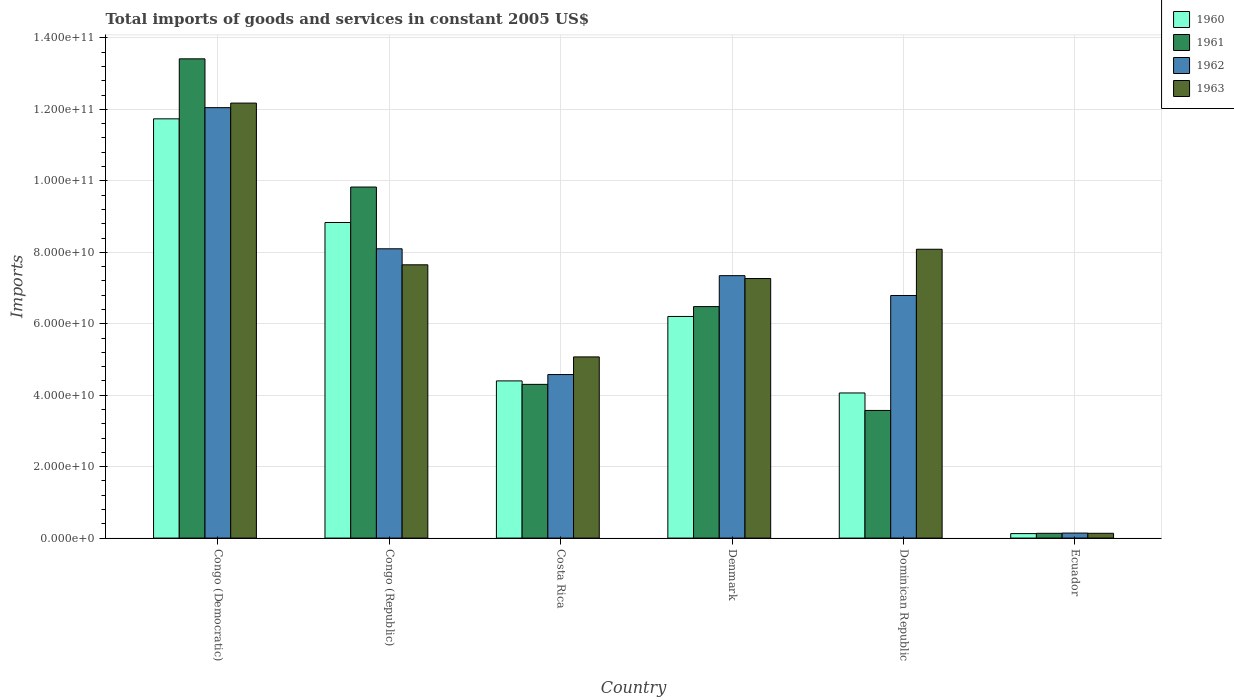How many groups of bars are there?
Offer a very short reply. 6. Are the number of bars on each tick of the X-axis equal?
Your response must be concise. Yes. How many bars are there on the 4th tick from the left?
Provide a short and direct response. 4. In how many cases, is the number of bars for a given country not equal to the number of legend labels?
Make the answer very short. 0. What is the total imports of goods and services in 1962 in Costa Rica?
Your answer should be compact. 4.58e+1. Across all countries, what is the maximum total imports of goods and services in 1961?
Provide a succinct answer. 1.34e+11. Across all countries, what is the minimum total imports of goods and services in 1963?
Offer a terse response. 1.34e+09. In which country was the total imports of goods and services in 1960 maximum?
Your answer should be compact. Congo (Democratic). In which country was the total imports of goods and services in 1961 minimum?
Your answer should be compact. Ecuador. What is the total total imports of goods and services in 1960 in the graph?
Offer a terse response. 3.54e+11. What is the difference between the total imports of goods and services in 1963 in Denmark and that in Ecuador?
Offer a very short reply. 7.13e+1. What is the difference between the total imports of goods and services in 1962 in Denmark and the total imports of goods and services in 1960 in Costa Rica?
Your answer should be very brief. 2.95e+1. What is the average total imports of goods and services in 1961 per country?
Your answer should be compact. 6.29e+1. What is the difference between the total imports of goods and services of/in 1962 and total imports of goods and services of/in 1960 in Ecuador?
Ensure brevity in your answer.  1.45e+08. In how many countries, is the total imports of goods and services in 1960 greater than 44000000000 US$?
Give a very brief answer. 4. What is the ratio of the total imports of goods and services in 1963 in Costa Rica to that in Denmark?
Your answer should be compact. 0.7. Is the difference between the total imports of goods and services in 1962 in Congo (Democratic) and Denmark greater than the difference between the total imports of goods and services in 1960 in Congo (Democratic) and Denmark?
Make the answer very short. No. What is the difference between the highest and the second highest total imports of goods and services in 1960?
Your response must be concise. -5.53e+1. What is the difference between the highest and the lowest total imports of goods and services in 1960?
Provide a short and direct response. 1.16e+11. In how many countries, is the total imports of goods and services in 1962 greater than the average total imports of goods and services in 1962 taken over all countries?
Offer a very short reply. 4. Is the sum of the total imports of goods and services in 1962 in Costa Rica and Denmark greater than the maximum total imports of goods and services in 1960 across all countries?
Give a very brief answer. Yes. Is it the case that in every country, the sum of the total imports of goods and services in 1962 and total imports of goods and services in 1961 is greater than the total imports of goods and services in 1960?
Your answer should be compact. Yes. How many countries are there in the graph?
Provide a short and direct response. 6. What is the difference between two consecutive major ticks on the Y-axis?
Provide a succinct answer. 2.00e+1. Are the values on the major ticks of Y-axis written in scientific E-notation?
Keep it short and to the point. Yes. Does the graph contain grids?
Offer a terse response. Yes. Where does the legend appear in the graph?
Your answer should be compact. Top right. How many legend labels are there?
Provide a short and direct response. 4. What is the title of the graph?
Offer a terse response. Total imports of goods and services in constant 2005 US$. What is the label or title of the Y-axis?
Your answer should be compact. Imports. What is the Imports in 1960 in Congo (Democratic)?
Provide a succinct answer. 1.17e+11. What is the Imports of 1961 in Congo (Democratic)?
Give a very brief answer. 1.34e+11. What is the Imports of 1962 in Congo (Democratic)?
Give a very brief answer. 1.20e+11. What is the Imports in 1963 in Congo (Democratic)?
Offer a very short reply. 1.22e+11. What is the Imports of 1960 in Congo (Republic)?
Provide a short and direct response. 8.83e+1. What is the Imports of 1961 in Congo (Republic)?
Your response must be concise. 9.83e+1. What is the Imports of 1962 in Congo (Republic)?
Offer a terse response. 8.10e+1. What is the Imports in 1963 in Congo (Republic)?
Your answer should be compact. 7.65e+1. What is the Imports in 1960 in Costa Rica?
Make the answer very short. 4.40e+1. What is the Imports in 1961 in Costa Rica?
Your answer should be compact. 4.30e+1. What is the Imports in 1962 in Costa Rica?
Ensure brevity in your answer.  4.58e+1. What is the Imports of 1963 in Costa Rica?
Provide a short and direct response. 5.07e+1. What is the Imports of 1960 in Denmark?
Keep it short and to the point. 6.20e+1. What is the Imports of 1961 in Denmark?
Offer a very short reply. 6.48e+1. What is the Imports of 1962 in Denmark?
Provide a succinct answer. 7.35e+1. What is the Imports of 1963 in Denmark?
Your answer should be compact. 7.27e+1. What is the Imports of 1960 in Dominican Republic?
Ensure brevity in your answer.  4.06e+1. What is the Imports of 1961 in Dominican Republic?
Offer a very short reply. 3.57e+1. What is the Imports in 1962 in Dominican Republic?
Your answer should be compact. 6.79e+1. What is the Imports in 1963 in Dominican Republic?
Make the answer very short. 8.09e+1. What is the Imports in 1960 in Ecuador?
Give a very brief answer. 1.26e+09. What is the Imports in 1961 in Ecuador?
Provide a succinct answer. 1.34e+09. What is the Imports in 1962 in Ecuador?
Your answer should be compact. 1.40e+09. What is the Imports of 1963 in Ecuador?
Your response must be concise. 1.34e+09. Across all countries, what is the maximum Imports in 1960?
Offer a terse response. 1.17e+11. Across all countries, what is the maximum Imports in 1961?
Give a very brief answer. 1.34e+11. Across all countries, what is the maximum Imports of 1962?
Provide a short and direct response. 1.20e+11. Across all countries, what is the maximum Imports in 1963?
Your response must be concise. 1.22e+11. Across all countries, what is the minimum Imports of 1960?
Your response must be concise. 1.26e+09. Across all countries, what is the minimum Imports in 1961?
Provide a succinct answer. 1.34e+09. Across all countries, what is the minimum Imports in 1962?
Provide a succinct answer. 1.40e+09. Across all countries, what is the minimum Imports in 1963?
Make the answer very short. 1.34e+09. What is the total Imports in 1960 in the graph?
Give a very brief answer. 3.54e+11. What is the total Imports of 1961 in the graph?
Keep it short and to the point. 3.77e+11. What is the total Imports in 1962 in the graph?
Make the answer very short. 3.90e+11. What is the total Imports in 1963 in the graph?
Give a very brief answer. 4.04e+11. What is the difference between the Imports in 1960 in Congo (Democratic) and that in Congo (Republic)?
Give a very brief answer. 2.90e+1. What is the difference between the Imports in 1961 in Congo (Democratic) and that in Congo (Republic)?
Your answer should be compact. 3.59e+1. What is the difference between the Imports of 1962 in Congo (Democratic) and that in Congo (Republic)?
Offer a terse response. 3.95e+1. What is the difference between the Imports of 1963 in Congo (Democratic) and that in Congo (Republic)?
Your answer should be very brief. 4.53e+1. What is the difference between the Imports in 1960 in Congo (Democratic) and that in Costa Rica?
Offer a very short reply. 7.34e+1. What is the difference between the Imports in 1961 in Congo (Democratic) and that in Costa Rica?
Keep it short and to the point. 9.11e+1. What is the difference between the Imports in 1962 in Congo (Democratic) and that in Costa Rica?
Provide a succinct answer. 7.47e+1. What is the difference between the Imports of 1963 in Congo (Democratic) and that in Costa Rica?
Your answer should be compact. 7.11e+1. What is the difference between the Imports in 1960 in Congo (Democratic) and that in Denmark?
Your response must be concise. 5.53e+1. What is the difference between the Imports in 1961 in Congo (Democratic) and that in Denmark?
Offer a terse response. 6.94e+1. What is the difference between the Imports of 1962 in Congo (Democratic) and that in Denmark?
Keep it short and to the point. 4.70e+1. What is the difference between the Imports of 1963 in Congo (Democratic) and that in Denmark?
Your response must be concise. 4.91e+1. What is the difference between the Imports of 1960 in Congo (Democratic) and that in Dominican Republic?
Provide a succinct answer. 7.67e+1. What is the difference between the Imports of 1961 in Congo (Democratic) and that in Dominican Republic?
Your answer should be compact. 9.84e+1. What is the difference between the Imports in 1962 in Congo (Democratic) and that in Dominican Republic?
Provide a succinct answer. 5.26e+1. What is the difference between the Imports in 1963 in Congo (Democratic) and that in Dominican Republic?
Your answer should be compact. 4.09e+1. What is the difference between the Imports in 1960 in Congo (Democratic) and that in Ecuador?
Your answer should be compact. 1.16e+11. What is the difference between the Imports of 1961 in Congo (Democratic) and that in Ecuador?
Your answer should be compact. 1.33e+11. What is the difference between the Imports of 1962 in Congo (Democratic) and that in Ecuador?
Offer a terse response. 1.19e+11. What is the difference between the Imports in 1963 in Congo (Democratic) and that in Ecuador?
Offer a very short reply. 1.20e+11. What is the difference between the Imports in 1960 in Congo (Republic) and that in Costa Rica?
Provide a short and direct response. 4.43e+1. What is the difference between the Imports of 1961 in Congo (Republic) and that in Costa Rica?
Offer a very short reply. 5.52e+1. What is the difference between the Imports in 1962 in Congo (Republic) and that in Costa Rica?
Your answer should be compact. 3.52e+1. What is the difference between the Imports in 1963 in Congo (Republic) and that in Costa Rica?
Offer a terse response. 2.58e+1. What is the difference between the Imports of 1960 in Congo (Republic) and that in Denmark?
Your response must be concise. 2.63e+1. What is the difference between the Imports in 1961 in Congo (Republic) and that in Denmark?
Your answer should be compact. 3.35e+1. What is the difference between the Imports of 1962 in Congo (Republic) and that in Denmark?
Your response must be concise. 7.52e+09. What is the difference between the Imports of 1963 in Congo (Republic) and that in Denmark?
Ensure brevity in your answer.  3.84e+09. What is the difference between the Imports of 1960 in Congo (Republic) and that in Dominican Republic?
Keep it short and to the point. 4.77e+1. What is the difference between the Imports of 1961 in Congo (Republic) and that in Dominican Republic?
Keep it short and to the point. 6.25e+1. What is the difference between the Imports of 1962 in Congo (Republic) and that in Dominican Republic?
Ensure brevity in your answer.  1.31e+1. What is the difference between the Imports in 1963 in Congo (Republic) and that in Dominican Republic?
Keep it short and to the point. -4.35e+09. What is the difference between the Imports of 1960 in Congo (Republic) and that in Ecuador?
Ensure brevity in your answer.  8.71e+1. What is the difference between the Imports in 1961 in Congo (Republic) and that in Ecuador?
Provide a succinct answer. 9.69e+1. What is the difference between the Imports of 1962 in Congo (Republic) and that in Ecuador?
Make the answer very short. 7.96e+1. What is the difference between the Imports in 1963 in Congo (Republic) and that in Ecuador?
Your response must be concise. 7.52e+1. What is the difference between the Imports in 1960 in Costa Rica and that in Denmark?
Your answer should be compact. -1.80e+1. What is the difference between the Imports of 1961 in Costa Rica and that in Denmark?
Provide a short and direct response. -2.18e+1. What is the difference between the Imports of 1962 in Costa Rica and that in Denmark?
Provide a succinct answer. -2.77e+1. What is the difference between the Imports in 1963 in Costa Rica and that in Denmark?
Ensure brevity in your answer.  -2.19e+1. What is the difference between the Imports of 1960 in Costa Rica and that in Dominican Republic?
Provide a succinct answer. 3.38e+09. What is the difference between the Imports of 1961 in Costa Rica and that in Dominican Republic?
Offer a very short reply. 7.30e+09. What is the difference between the Imports in 1962 in Costa Rica and that in Dominican Republic?
Offer a terse response. -2.21e+1. What is the difference between the Imports in 1963 in Costa Rica and that in Dominican Republic?
Keep it short and to the point. -3.01e+1. What is the difference between the Imports in 1960 in Costa Rica and that in Ecuador?
Offer a terse response. 4.27e+1. What is the difference between the Imports of 1961 in Costa Rica and that in Ecuador?
Ensure brevity in your answer.  4.17e+1. What is the difference between the Imports of 1962 in Costa Rica and that in Ecuador?
Your response must be concise. 4.44e+1. What is the difference between the Imports of 1963 in Costa Rica and that in Ecuador?
Your answer should be compact. 4.94e+1. What is the difference between the Imports in 1960 in Denmark and that in Dominican Republic?
Make the answer very short. 2.14e+1. What is the difference between the Imports in 1961 in Denmark and that in Dominican Republic?
Provide a short and direct response. 2.91e+1. What is the difference between the Imports in 1962 in Denmark and that in Dominican Republic?
Provide a short and direct response. 5.55e+09. What is the difference between the Imports of 1963 in Denmark and that in Dominican Republic?
Offer a very short reply. -8.19e+09. What is the difference between the Imports in 1960 in Denmark and that in Ecuador?
Ensure brevity in your answer.  6.08e+1. What is the difference between the Imports in 1961 in Denmark and that in Ecuador?
Offer a terse response. 6.35e+1. What is the difference between the Imports of 1962 in Denmark and that in Ecuador?
Keep it short and to the point. 7.21e+1. What is the difference between the Imports of 1963 in Denmark and that in Ecuador?
Give a very brief answer. 7.13e+1. What is the difference between the Imports in 1960 in Dominican Republic and that in Ecuador?
Offer a terse response. 3.94e+1. What is the difference between the Imports of 1961 in Dominican Republic and that in Ecuador?
Make the answer very short. 3.44e+1. What is the difference between the Imports of 1962 in Dominican Republic and that in Ecuador?
Offer a very short reply. 6.65e+1. What is the difference between the Imports of 1963 in Dominican Republic and that in Ecuador?
Provide a succinct answer. 7.95e+1. What is the difference between the Imports of 1960 in Congo (Democratic) and the Imports of 1961 in Congo (Republic)?
Provide a succinct answer. 1.91e+1. What is the difference between the Imports in 1960 in Congo (Democratic) and the Imports in 1962 in Congo (Republic)?
Provide a succinct answer. 3.64e+1. What is the difference between the Imports in 1960 in Congo (Democratic) and the Imports in 1963 in Congo (Republic)?
Your response must be concise. 4.09e+1. What is the difference between the Imports of 1961 in Congo (Democratic) and the Imports of 1962 in Congo (Republic)?
Your answer should be very brief. 5.32e+1. What is the difference between the Imports of 1961 in Congo (Democratic) and the Imports of 1963 in Congo (Republic)?
Make the answer very short. 5.77e+1. What is the difference between the Imports of 1962 in Congo (Democratic) and the Imports of 1963 in Congo (Republic)?
Offer a very short reply. 4.40e+1. What is the difference between the Imports of 1960 in Congo (Democratic) and the Imports of 1961 in Costa Rica?
Provide a succinct answer. 7.43e+1. What is the difference between the Imports in 1960 in Congo (Democratic) and the Imports in 1962 in Costa Rica?
Keep it short and to the point. 7.16e+1. What is the difference between the Imports in 1960 in Congo (Democratic) and the Imports in 1963 in Costa Rica?
Offer a very short reply. 6.66e+1. What is the difference between the Imports of 1961 in Congo (Democratic) and the Imports of 1962 in Costa Rica?
Give a very brief answer. 8.84e+1. What is the difference between the Imports in 1961 in Congo (Democratic) and the Imports in 1963 in Costa Rica?
Provide a succinct answer. 8.34e+1. What is the difference between the Imports in 1962 in Congo (Democratic) and the Imports in 1963 in Costa Rica?
Provide a short and direct response. 6.98e+1. What is the difference between the Imports of 1960 in Congo (Democratic) and the Imports of 1961 in Denmark?
Your answer should be compact. 5.26e+1. What is the difference between the Imports in 1960 in Congo (Democratic) and the Imports in 1962 in Denmark?
Keep it short and to the point. 4.39e+1. What is the difference between the Imports in 1960 in Congo (Democratic) and the Imports in 1963 in Denmark?
Your answer should be very brief. 4.47e+1. What is the difference between the Imports in 1961 in Congo (Democratic) and the Imports in 1962 in Denmark?
Keep it short and to the point. 6.07e+1. What is the difference between the Imports in 1961 in Congo (Democratic) and the Imports in 1963 in Denmark?
Provide a succinct answer. 6.15e+1. What is the difference between the Imports in 1962 in Congo (Democratic) and the Imports in 1963 in Denmark?
Provide a short and direct response. 4.78e+1. What is the difference between the Imports of 1960 in Congo (Democratic) and the Imports of 1961 in Dominican Republic?
Give a very brief answer. 8.16e+1. What is the difference between the Imports in 1960 in Congo (Democratic) and the Imports in 1962 in Dominican Republic?
Offer a terse response. 4.95e+1. What is the difference between the Imports of 1960 in Congo (Democratic) and the Imports of 1963 in Dominican Republic?
Your response must be concise. 3.65e+1. What is the difference between the Imports of 1961 in Congo (Democratic) and the Imports of 1962 in Dominican Republic?
Your answer should be compact. 6.62e+1. What is the difference between the Imports in 1961 in Congo (Democratic) and the Imports in 1963 in Dominican Republic?
Keep it short and to the point. 5.33e+1. What is the difference between the Imports of 1962 in Congo (Democratic) and the Imports of 1963 in Dominican Republic?
Your response must be concise. 3.96e+1. What is the difference between the Imports of 1960 in Congo (Democratic) and the Imports of 1961 in Ecuador?
Give a very brief answer. 1.16e+11. What is the difference between the Imports in 1960 in Congo (Democratic) and the Imports in 1962 in Ecuador?
Your answer should be very brief. 1.16e+11. What is the difference between the Imports in 1960 in Congo (Democratic) and the Imports in 1963 in Ecuador?
Make the answer very short. 1.16e+11. What is the difference between the Imports of 1961 in Congo (Democratic) and the Imports of 1962 in Ecuador?
Make the answer very short. 1.33e+11. What is the difference between the Imports of 1961 in Congo (Democratic) and the Imports of 1963 in Ecuador?
Provide a succinct answer. 1.33e+11. What is the difference between the Imports of 1962 in Congo (Democratic) and the Imports of 1963 in Ecuador?
Give a very brief answer. 1.19e+11. What is the difference between the Imports in 1960 in Congo (Republic) and the Imports in 1961 in Costa Rica?
Ensure brevity in your answer.  4.53e+1. What is the difference between the Imports of 1960 in Congo (Republic) and the Imports of 1962 in Costa Rica?
Provide a succinct answer. 4.26e+1. What is the difference between the Imports in 1960 in Congo (Republic) and the Imports in 1963 in Costa Rica?
Offer a very short reply. 3.76e+1. What is the difference between the Imports in 1961 in Congo (Republic) and the Imports in 1962 in Costa Rica?
Offer a terse response. 5.25e+1. What is the difference between the Imports of 1961 in Congo (Republic) and the Imports of 1963 in Costa Rica?
Your answer should be very brief. 4.76e+1. What is the difference between the Imports of 1962 in Congo (Republic) and the Imports of 1963 in Costa Rica?
Provide a short and direct response. 3.03e+1. What is the difference between the Imports in 1960 in Congo (Republic) and the Imports in 1961 in Denmark?
Provide a succinct answer. 2.35e+1. What is the difference between the Imports in 1960 in Congo (Republic) and the Imports in 1962 in Denmark?
Keep it short and to the point. 1.49e+1. What is the difference between the Imports of 1960 in Congo (Republic) and the Imports of 1963 in Denmark?
Keep it short and to the point. 1.57e+1. What is the difference between the Imports of 1961 in Congo (Republic) and the Imports of 1962 in Denmark?
Provide a short and direct response. 2.48e+1. What is the difference between the Imports of 1961 in Congo (Republic) and the Imports of 1963 in Denmark?
Your answer should be very brief. 2.56e+1. What is the difference between the Imports in 1962 in Congo (Republic) and the Imports in 1963 in Denmark?
Your response must be concise. 8.32e+09. What is the difference between the Imports of 1960 in Congo (Republic) and the Imports of 1961 in Dominican Republic?
Your response must be concise. 5.26e+1. What is the difference between the Imports in 1960 in Congo (Republic) and the Imports in 1962 in Dominican Republic?
Your answer should be very brief. 2.04e+1. What is the difference between the Imports of 1960 in Congo (Republic) and the Imports of 1963 in Dominican Republic?
Your response must be concise. 7.49e+09. What is the difference between the Imports in 1961 in Congo (Republic) and the Imports in 1962 in Dominican Republic?
Give a very brief answer. 3.04e+1. What is the difference between the Imports of 1961 in Congo (Republic) and the Imports of 1963 in Dominican Republic?
Give a very brief answer. 1.74e+1. What is the difference between the Imports of 1962 in Congo (Republic) and the Imports of 1963 in Dominican Republic?
Offer a terse response. 1.31e+08. What is the difference between the Imports in 1960 in Congo (Republic) and the Imports in 1961 in Ecuador?
Provide a short and direct response. 8.70e+1. What is the difference between the Imports of 1960 in Congo (Republic) and the Imports of 1962 in Ecuador?
Your response must be concise. 8.69e+1. What is the difference between the Imports in 1960 in Congo (Republic) and the Imports in 1963 in Ecuador?
Ensure brevity in your answer.  8.70e+1. What is the difference between the Imports of 1961 in Congo (Republic) and the Imports of 1962 in Ecuador?
Provide a short and direct response. 9.69e+1. What is the difference between the Imports of 1961 in Congo (Republic) and the Imports of 1963 in Ecuador?
Offer a very short reply. 9.69e+1. What is the difference between the Imports in 1962 in Congo (Republic) and the Imports in 1963 in Ecuador?
Your response must be concise. 7.96e+1. What is the difference between the Imports of 1960 in Costa Rica and the Imports of 1961 in Denmark?
Offer a very short reply. -2.08e+1. What is the difference between the Imports in 1960 in Costa Rica and the Imports in 1962 in Denmark?
Give a very brief answer. -2.95e+1. What is the difference between the Imports of 1960 in Costa Rica and the Imports of 1963 in Denmark?
Your answer should be very brief. -2.87e+1. What is the difference between the Imports of 1961 in Costa Rica and the Imports of 1962 in Denmark?
Your answer should be very brief. -3.04e+1. What is the difference between the Imports of 1961 in Costa Rica and the Imports of 1963 in Denmark?
Give a very brief answer. -2.96e+1. What is the difference between the Imports in 1962 in Costa Rica and the Imports in 1963 in Denmark?
Your answer should be very brief. -2.69e+1. What is the difference between the Imports in 1960 in Costa Rica and the Imports in 1961 in Dominican Republic?
Provide a succinct answer. 8.27e+09. What is the difference between the Imports in 1960 in Costa Rica and the Imports in 1962 in Dominican Republic?
Give a very brief answer. -2.39e+1. What is the difference between the Imports of 1960 in Costa Rica and the Imports of 1963 in Dominican Republic?
Ensure brevity in your answer.  -3.68e+1. What is the difference between the Imports in 1961 in Costa Rica and the Imports in 1962 in Dominican Republic?
Offer a very short reply. -2.49e+1. What is the difference between the Imports of 1961 in Costa Rica and the Imports of 1963 in Dominican Republic?
Your response must be concise. -3.78e+1. What is the difference between the Imports of 1962 in Costa Rica and the Imports of 1963 in Dominican Republic?
Your response must be concise. -3.51e+1. What is the difference between the Imports in 1960 in Costa Rica and the Imports in 1961 in Ecuador?
Your response must be concise. 4.27e+1. What is the difference between the Imports of 1960 in Costa Rica and the Imports of 1962 in Ecuador?
Your answer should be very brief. 4.26e+1. What is the difference between the Imports in 1960 in Costa Rica and the Imports in 1963 in Ecuador?
Provide a short and direct response. 4.27e+1. What is the difference between the Imports in 1961 in Costa Rica and the Imports in 1962 in Ecuador?
Provide a succinct answer. 4.16e+1. What is the difference between the Imports in 1961 in Costa Rica and the Imports in 1963 in Ecuador?
Your answer should be very brief. 4.17e+1. What is the difference between the Imports of 1962 in Costa Rica and the Imports of 1963 in Ecuador?
Your answer should be compact. 4.44e+1. What is the difference between the Imports in 1960 in Denmark and the Imports in 1961 in Dominican Republic?
Keep it short and to the point. 2.63e+1. What is the difference between the Imports in 1960 in Denmark and the Imports in 1962 in Dominican Republic?
Offer a terse response. -5.87e+09. What is the difference between the Imports in 1960 in Denmark and the Imports in 1963 in Dominican Republic?
Offer a terse response. -1.88e+1. What is the difference between the Imports of 1961 in Denmark and the Imports of 1962 in Dominican Republic?
Your answer should be compact. -3.11e+09. What is the difference between the Imports in 1961 in Denmark and the Imports in 1963 in Dominican Republic?
Make the answer very short. -1.61e+1. What is the difference between the Imports in 1962 in Denmark and the Imports in 1963 in Dominican Republic?
Provide a short and direct response. -7.39e+09. What is the difference between the Imports of 1960 in Denmark and the Imports of 1961 in Ecuador?
Your answer should be very brief. 6.07e+1. What is the difference between the Imports of 1960 in Denmark and the Imports of 1962 in Ecuador?
Provide a short and direct response. 6.06e+1. What is the difference between the Imports in 1960 in Denmark and the Imports in 1963 in Ecuador?
Offer a terse response. 6.07e+1. What is the difference between the Imports of 1961 in Denmark and the Imports of 1962 in Ecuador?
Give a very brief answer. 6.34e+1. What is the difference between the Imports of 1961 in Denmark and the Imports of 1963 in Ecuador?
Give a very brief answer. 6.35e+1. What is the difference between the Imports of 1962 in Denmark and the Imports of 1963 in Ecuador?
Offer a terse response. 7.21e+1. What is the difference between the Imports of 1960 in Dominican Republic and the Imports of 1961 in Ecuador?
Offer a very short reply. 3.93e+1. What is the difference between the Imports in 1960 in Dominican Republic and the Imports in 1962 in Ecuador?
Keep it short and to the point. 3.92e+1. What is the difference between the Imports of 1960 in Dominican Republic and the Imports of 1963 in Ecuador?
Give a very brief answer. 3.93e+1. What is the difference between the Imports in 1961 in Dominican Republic and the Imports in 1962 in Ecuador?
Offer a very short reply. 3.43e+1. What is the difference between the Imports of 1961 in Dominican Republic and the Imports of 1963 in Ecuador?
Make the answer very short. 3.44e+1. What is the difference between the Imports in 1962 in Dominican Republic and the Imports in 1963 in Ecuador?
Keep it short and to the point. 6.66e+1. What is the average Imports in 1960 per country?
Ensure brevity in your answer.  5.89e+1. What is the average Imports of 1961 per country?
Keep it short and to the point. 6.29e+1. What is the average Imports of 1962 per country?
Keep it short and to the point. 6.50e+1. What is the average Imports in 1963 per country?
Provide a short and direct response. 6.73e+1. What is the difference between the Imports of 1960 and Imports of 1961 in Congo (Democratic)?
Make the answer very short. -1.68e+1. What is the difference between the Imports in 1960 and Imports in 1962 in Congo (Democratic)?
Give a very brief answer. -3.13e+09. What is the difference between the Imports of 1960 and Imports of 1963 in Congo (Democratic)?
Your answer should be very brief. -4.41e+09. What is the difference between the Imports in 1961 and Imports in 1962 in Congo (Democratic)?
Offer a very short reply. 1.37e+1. What is the difference between the Imports in 1961 and Imports in 1963 in Congo (Democratic)?
Give a very brief answer. 1.24e+1. What is the difference between the Imports in 1962 and Imports in 1963 in Congo (Democratic)?
Ensure brevity in your answer.  -1.28e+09. What is the difference between the Imports in 1960 and Imports in 1961 in Congo (Republic)?
Offer a very short reply. -9.92e+09. What is the difference between the Imports in 1960 and Imports in 1962 in Congo (Republic)?
Offer a very short reply. 7.36e+09. What is the difference between the Imports in 1960 and Imports in 1963 in Congo (Republic)?
Give a very brief answer. 1.18e+1. What is the difference between the Imports of 1961 and Imports of 1962 in Congo (Republic)?
Make the answer very short. 1.73e+1. What is the difference between the Imports of 1961 and Imports of 1963 in Congo (Republic)?
Give a very brief answer. 2.18e+1. What is the difference between the Imports of 1962 and Imports of 1963 in Congo (Republic)?
Provide a succinct answer. 4.48e+09. What is the difference between the Imports in 1960 and Imports in 1961 in Costa Rica?
Make the answer very short. 9.75e+08. What is the difference between the Imports in 1960 and Imports in 1962 in Costa Rica?
Your answer should be very brief. -1.77e+09. What is the difference between the Imports of 1960 and Imports of 1963 in Costa Rica?
Ensure brevity in your answer.  -6.71e+09. What is the difference between the Imports of 1961 and Imports of 1962 in Costa Rica?
Your answer should be compact. -2.75e+09. What is the difference between the Imports in 1961 and Imports in 1963 in Costa Rica?
Give a very brief answer. -7.69e+09. What is the difference between the Imports of 1962 and Imports of 1963 in Costa Rica?
Provide a short and direct response. -4.94e+09. What is the difference between the Imports of 1960 and Imports of 1961 in Denmark?
Keep it short and to the point. -2.76e+09. What is the difference between the Imports in 1960 and Imports in 1962 in Denmark?
Offer a terse response. -1.14e+1. What is the difference between the Imports in 1960 and Imports in 1963 in Denmark?
Offer a very short reply. -1.06e+1. What is the difference between the Imports of 1961 and Imports of 1962 in Denmark?
Your answer should be very brief. -8.66e+09. What is the difference between the Imports in 1961 and Imports in 1963 in Denmark?
Ensure brevity in your answer.  -7.86e+09. What is the difference between the Imports of 1962 and Imports of 1963 in Denmark?
Offer a terse response. 8.02e+08. What is the difference between the Imports in 1960 and Imports in 1961 in Dominican Republic?
Provide a succinct answer. 4.89e+09. What is the difference between the Imports in 1960 and Imports in 1962 in Dominican Republic?
Your answer should be very brief. -2.73e+1. What is the difference between the Imports of 1960 and Imports of 1963 in Dominican Republic?
Make the answer very short. -4.02e+1. What is the difference between the Imports of 1961 and Imports of 1962 in Dominican Republic?
Your response must be concise. -3.22e+1. What is the difference between the Imports of 1961 and Imports of 1963 in Dominican Republic?
Keep it short and to the point. -4.51e+1. What is the difference between the Imports of 1962 and Imports of 1963 in Dominican Republic?
Provide a short and direct response. -1.29e+1. What is the difference between the Imports of 1960 and Imports of 1961 in Ecuador?
Keep it short and to the point. -8.15e+07. What is the difference between the Imports in 1960 and Imports in 1962 in Ecuador?
Your answer should be compact. -1.45e+08. What is the difference between the Imports of 1960 and Imports of 1963 in Ecuador?
Keep it short and to the point. -8.51e+07. What is the difference between the Imports in 1961 and Imports in 1962 in Ecuador?
Offer a terse response. -6.38e+07. What is the difference between the Imports in 1961 and Imports in 1963 in Ecuador?
Your answer should be very brief. -3.54e+06. What is the difference between the Imports in 1962 and Imports in 1963 in Ecuador?
Provide a succinct answer. 6.03e+07. What is the ratio of the Imports of 1960 in Congo (Democratic) to that in Congo (Republic)?
Ensure brevity in your answer.  1.33. What is the ratio of the Imports in 1961 in Congo (Democratic) to that in Congo (Republic)?
Make the answer very short. 1.37. What is the ratio of the Imports of 1962 in Congo (Democratic) to that in Congo (Republic)?
Your answer should be compact. 1.49. What is the ratio of the Imports in 1963 in Congo (Democratic) to that in Congo (Republic)?
Your answer should be very brief. 1.59. What is the ratio of the Imports in 1960 in Congo (Democratic) to that in Costa Rica?
Offer a very short reply. 2.67. What is the ratio of the Imports of 1961 in Congo (Democratic) to that in Costa Rica?
Your answer should be very brief. 3.12. What is the ratio of the Imports in 1962 in Congo (Democratic) to that in Costa Rica?
Provide a succinct answer. 2.63. What is the ratio of the Imports of 1963 in Congo (Democratic) to that in Costa Rica?
Your response must be concise. 2.4. What is the ratio of the Imports in 1960 in Congo (Democratic) to that in Denmark?
Provide a short and direct response. 1.89. What is the ratio of the Imports in 1961 in Congo (Democratic) to that in Denmark?
Provide a short and direct response. 2.07. What is the ratio of the Imports in 1962 in Congo (Democratic) to that in Denmark?
Provide a short and direct response. 1.64. What is the ratio of the Imports of 1963 in Congo (Democratic) to that in Denmark?
Provide a short and direct response. 1.68. What is the ratio of the Imports of 1960 in Congo (Democratic) to that in Dominican Republic?
Offer a terse response. 2.89. What is the ratio of the Imports in 1961 in Congo (Democratic) to that in Dominican Republic?
Keep it short and to the point. 3.75. What is the ratio of the Imports in 1962 in Congo (Democratic) to that in Dominican Republic?
Provide a succinct answer. 1.77. What is the ratio of the Imports of 1963 in Congo (Democratic) to that in Dominican Republic?
Make the answer very short. 1.51. What is the ratio of the Imports of 1960 in Congo (Democratic) to that in Ecuador?
Your answer should be very brief. 93.27. What is the ratio of the Imports in 1961 in Congo (Democratic) to that in Ecuador?
Provide a succinct answer. 100.13. What is the ratio of the Imports in 1962 in Congo (Democratic) to that in Ecuador?
Your answer should be compact. 85.84. What is the ratio of the Imports in 1963 in Congo (Democratic) to that in Ecuador?
Provide a short and direct response. 90.65. What is the ratio of the Imports of 1960 in Congo (Republic) to that in Costa Rica?
Your answer should be compact. 2.01. What is the ratio of the Imports of 1961 in Congo (Republic) to that in Costa Rica?
Provide a succinct answer. 2.28. What is the ratio of the Imports in 1962 in Congo (Republic) to that in Costa Rica?
Make the answer very short. 1.77. What is the ratio of the Imports in 1963 in Congo (Republic) to that in Costa Rica?
Your answer should be compact. 1.51. What is the ratio of the Imports in 1960 in Congo (Republic) to that in Denmark?
Ensure brevity in your answer.  1.42. What is the ratio of the Imports of 1961 in Congo (Republic) to that in Denmark?
Offer a very short reply. 1.52. What is the ratio of the Imports in 1962 in Congo (Republic) to that in Denmark?
Give a very brief answer. 1.1. What is the ratio of the Imports in 1963 in Congo (Republic) to that in Denmark?
Provide a succinct answer. 1.05. What is the ratio of the Imports in 1960 in Congo (Republic) to that in Dominican Republic?
Your answer should be very brief. 2.17. What is the ratio of the Imports in 1961 in Congo (Republic) to that in Dominican Republic?
Give a very brief answer. 2.75. What is the ratio of the Imports of 1962 in Congo (Republic) to that in Dominican Republic?
Offer a very short reply. 1.19. What is the ratio of the Imports of 1963 in Congo (Republic) to that in Dominican Republic?
Ensure brevity in your answer.  0.95. What is the ratio of the Imports of 1960 in Congo (Republic) to that in Ecuador?
Offer a very short reply. 70.21. What is the ratio of the Imports in 1961 in Congo (Republic) to that in Ecuador?
Ensure brevity in your answer.  73.34. What is the ratio of the Imports of 1962 in Congo (Republic) to that in Ecuador?
Make the answer very short. 57.7. What is the ratio of the Imports in 1963 in Congo (Republic) to that in Ecuador?
Your response must be concise. 56.95. What is the ratio of the Imports in 1960 in Costa Rica to that in Denmark?
Provide a succinct answer. 0.71. What is the ratio of the Imports in 1961 in Costa Rica to that in Denmark?
Give a very brief answer. 0.66. What is the ratio of the Imports of 1962 in Costa Rica to that in Denmark?
Your response must be concise. 0.62. What is the ratio of the Imports of 1963 in Costa Rica to that in Denmark?
Make the answer very short. 0.7. What is the ratio of the Imports of 1960 in Costa Rica to that in Dominican Republic?
Your answer should be compact. 1.08. What is the ratio of the Imports of 1961 in Costa Rica to that in Dominican Republic?
Offer a very short reply. 1.2. What is the ratio of the Imports of 1962 in Costa Rica to that in Dominican Republic?
Your response must be concise. 0.67. What is the ratio of the Imports in 1963 in Costa Rica to that in Dominican Republic?
Offer a very short reply. 0.63. What is the ratio of the Imports in 1960 in Costa Rica to that in Ecuador?
Your answer should be compact. 34.97. What is the ratio of the Imports in 1961 in Costa Rica to that in Ecuador?
Keep it short and to the point. 32.12. What is the ratio of the Imports in 1962 in Costa Rica to that in Ecuador?
Make the answer very short. 32.62. What is the ratio of the Imports of 1963 in Costa Rica to that in Ecuador?
Provide a succinct answer. 37.75. What is the ratio of the Imports in 1960 in Denmark to that in Dominican Republic?
Your answer should be compact. 1.53. What is the ratio of the Imports in 1961 in Denmark to that in Dominican Republic?
Offer a very short reply. 1.81. What is the ratio of the Imports of 1962 in Denmark to that in Dominican Republic?
Offer a terse response. 1.08. What is the ratio of the Imports in 1963 in Denmark to that in Dominican Republic?
Your answer should be very brief. 0.9. What is the ratio of the Imports of 1960 in Denmark to that in Ecuador?
Give a very brief answer. 49.3. What is the ratio of the Imports of 1961 in Denmark to that in Ecuador?
Your answer should be very brief. 48.36. What is the ratio of the Imports in 1962 in Denmark to that in Ecuador?
Offer a very short reply. 52.34. What is the ratio of the Imports of 1963 in Denmark to that in Ecuador?
Give a very brief answer. 54.09. What is the ratio of the Imports of 1960 in Dominican Republic to that in Ecuador?
Keep it short and to the point. 32.29. What is the ratio of the Imports of 1961 in Dominican Republic to that in Ecuador?
Your answer should be very brief. 26.67. What is the ratio of the Imports of 1962 in Dominican Republic to that in Ecuador?
Make the answer very short. 48.38. What is the ratio of the Imports in 1963 in Dominican Republic to that in Ecuador?
Ensure brevity in your answer.  60.19. What is the difference between the highest and the second highest Imports in 1960?
Provide a succinct answer. 2.90e+1. What is the difference between the highest and the second highest Imports of 1961?
Offer a very short reply. 3.59e+1. What is the difference between the highest and the second highest Imports in 1962?
Your answer should be very brief. 3.95e+1. What is the difference between the highest and the second highest Imports in 1963?
Give a very brief answer. 4.09e+1. What is the difference between the highest and the lowest Imports of 1960?
Give a very brief answer. 1.16e+11. What is the difference between the highest and the lowest Imports in 1961?
Your answer should be compact. 1.33e+11. What is the difference between the highest and the lowest Imports of 1962?
Ensure brevity in your answer.  1.19e+11. What is the difference between the highest and the lowest Imports of 1963?
Your answer should be very brief. 1.20e+11. 